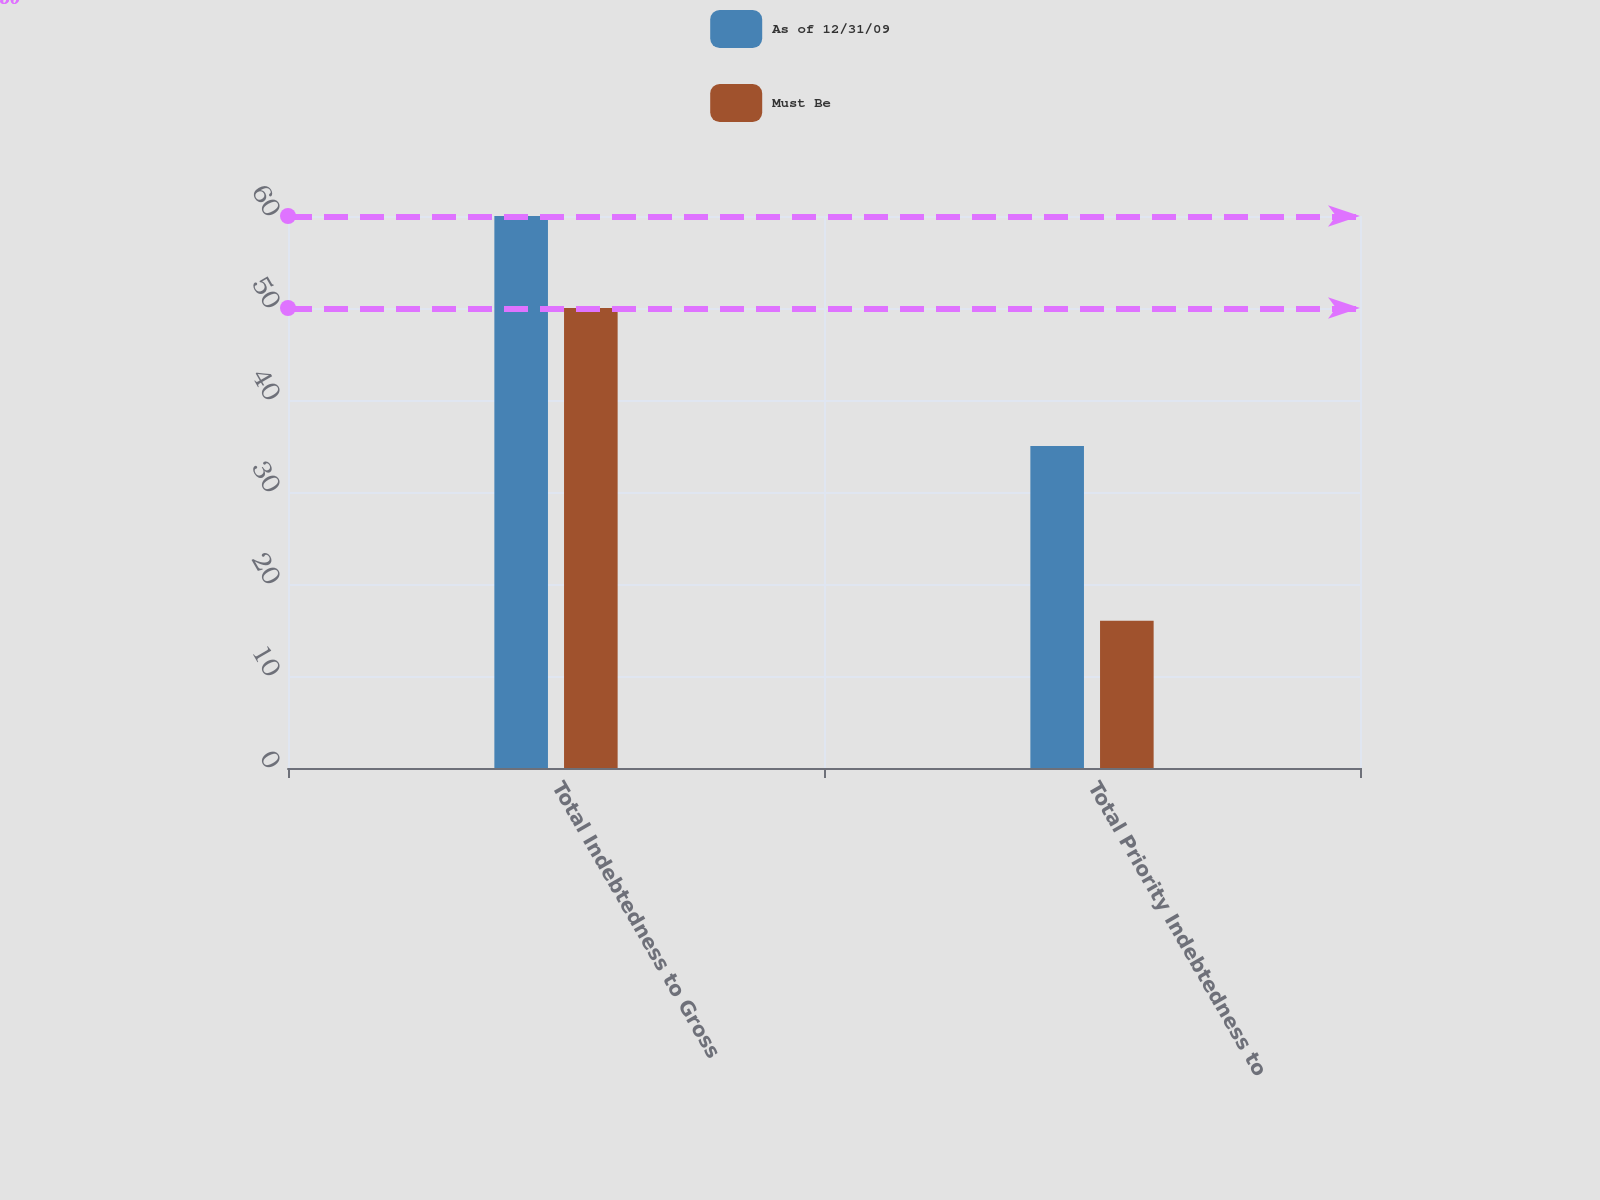Convert chart. <chart><loc_0><loc_0><loc_500><loc_500><stacked_bar_chart><ecel><fcel>Total Indebtedness to Gross<fcel>Total Priority Indebtedness to<nl><fcel>As of 12/31/09<fcel>60<fcel>35<nl><fcel>Must Be<fcel>50<fcel>16<nl></chart> 